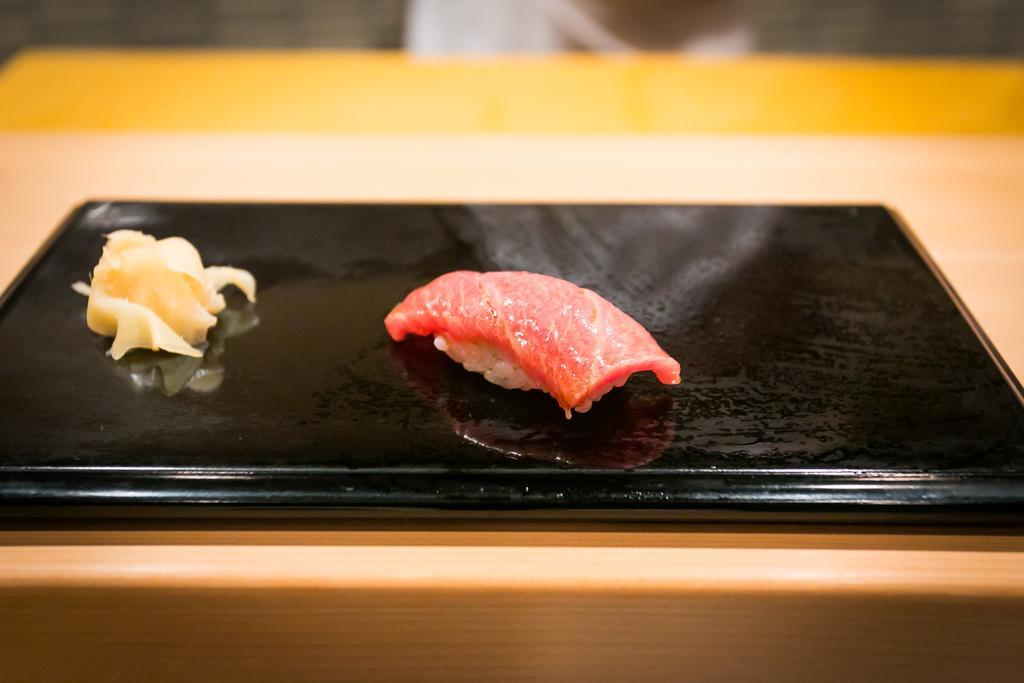Could you give a brief overview of what you see in this image? This image consists of a menu card. On which we can see the flesh. At the bottom, there is a table. 